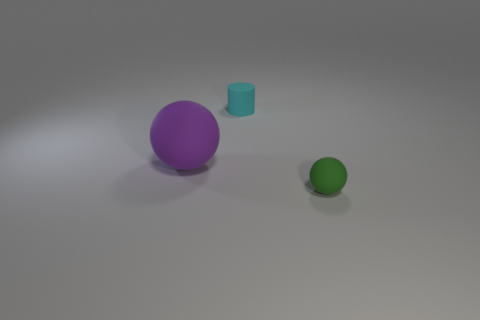Add 2 gray cylinders. How many objects exist? 5 Subtract all cylinders. How many objects are left? 2 Add 2 purple rubber balls. How many purple rubber balls exist? 3 Subtract 0 red cylinders. How many objects are left? 3 Subtract all large purple rubber things. Subtract all purple matte objects. How many objects are left? 1 Add 1 spheres. How many spheres are left? 3 